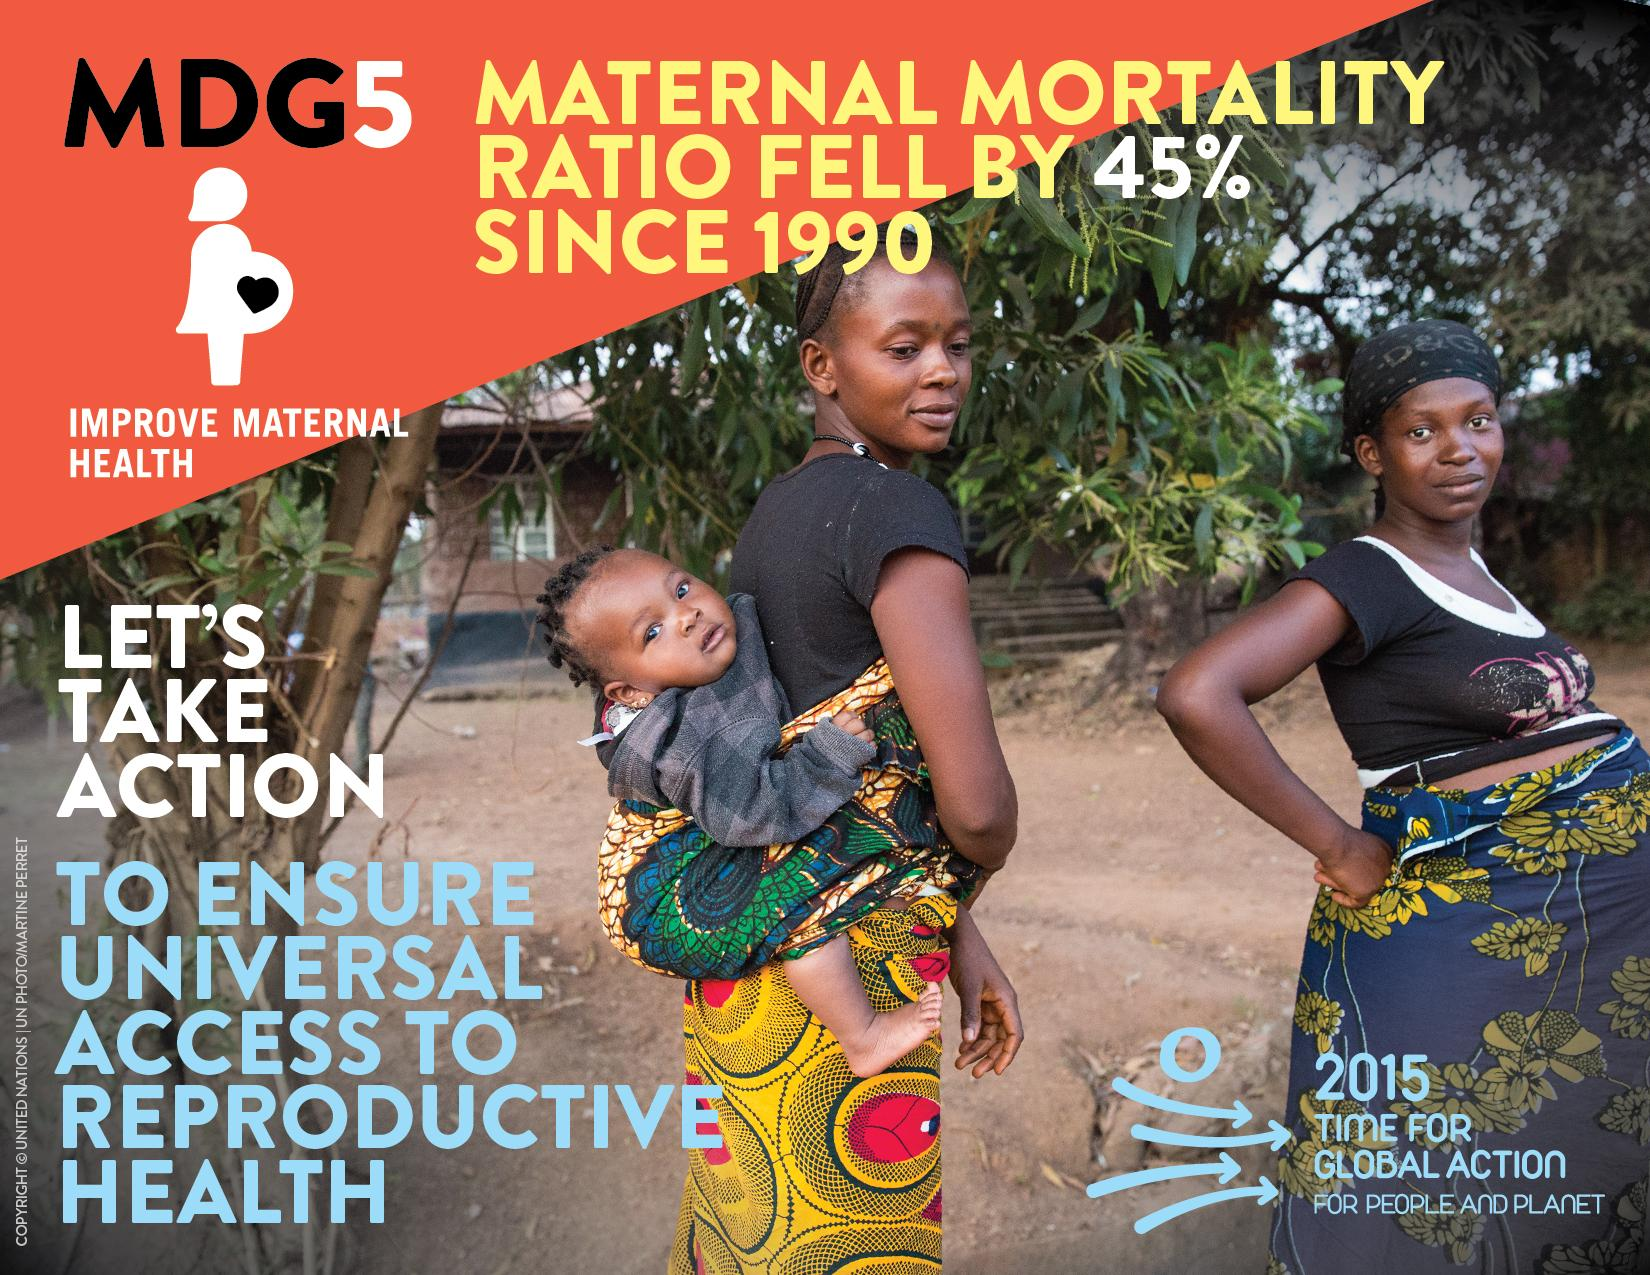Outline some significant characteristics in this image. There are two women depicted in this image. The image shows one child. 